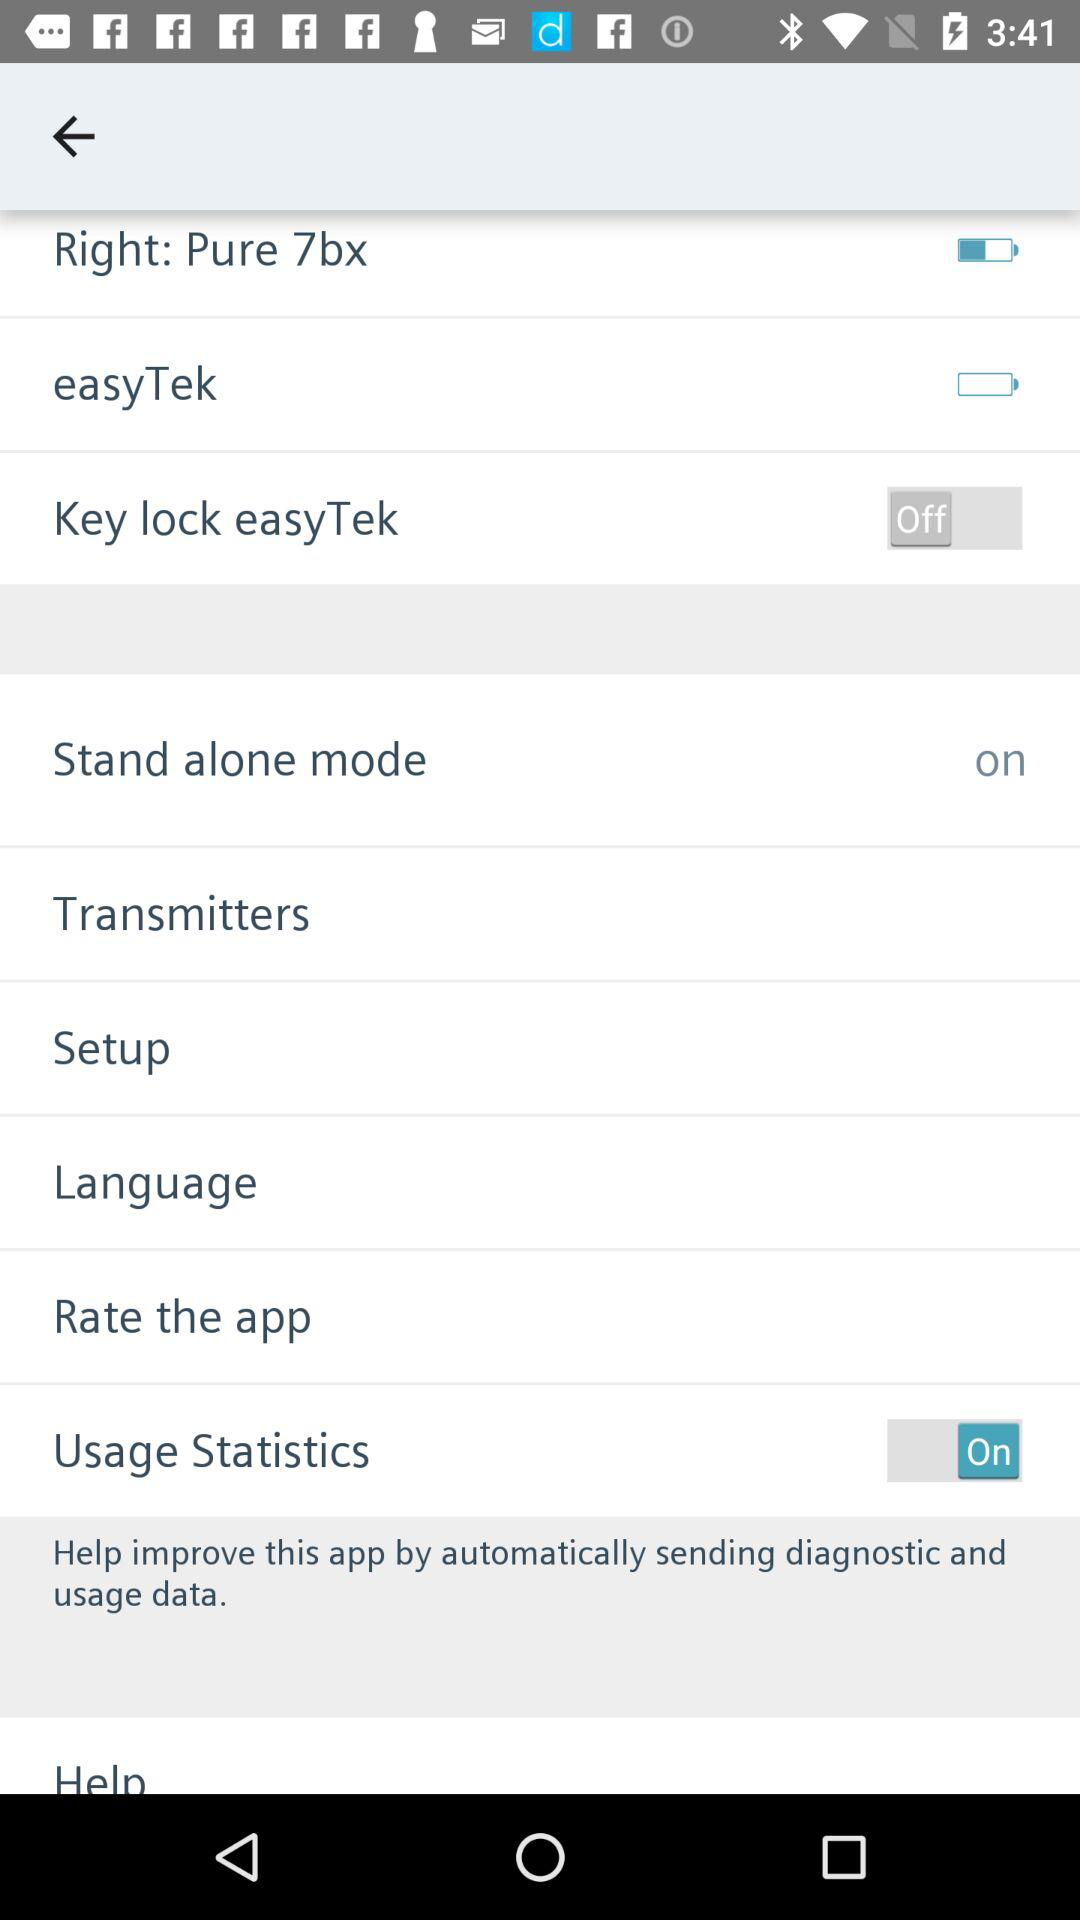What is the status of "Stand alone mode"? The status of "Stand alone mode" is on. 